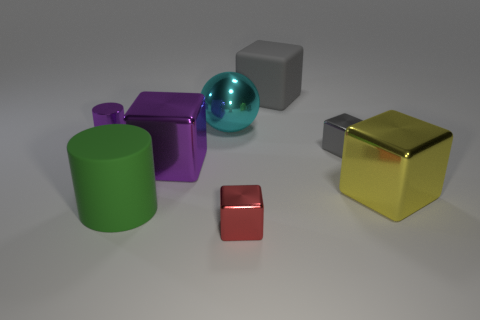Can you tell me the colors of the objects? Certainly, the cylinder is green, the cube to the right is golden with a shiny texture, the middle cube is gray, the sphere is turquoise with a reflective surface, and the small rectangular box is red. Lastly, the leftmost cube has a reflective purple surface. What can you say about the lighting in the scene? The lighting in the scene is soft and diffused, creating gentle shadows on the right side of the objects. This indicates that the light source is likely out of frame to the left. The lack of harsh shadows suggests an indoor setting with ambient lighting. 